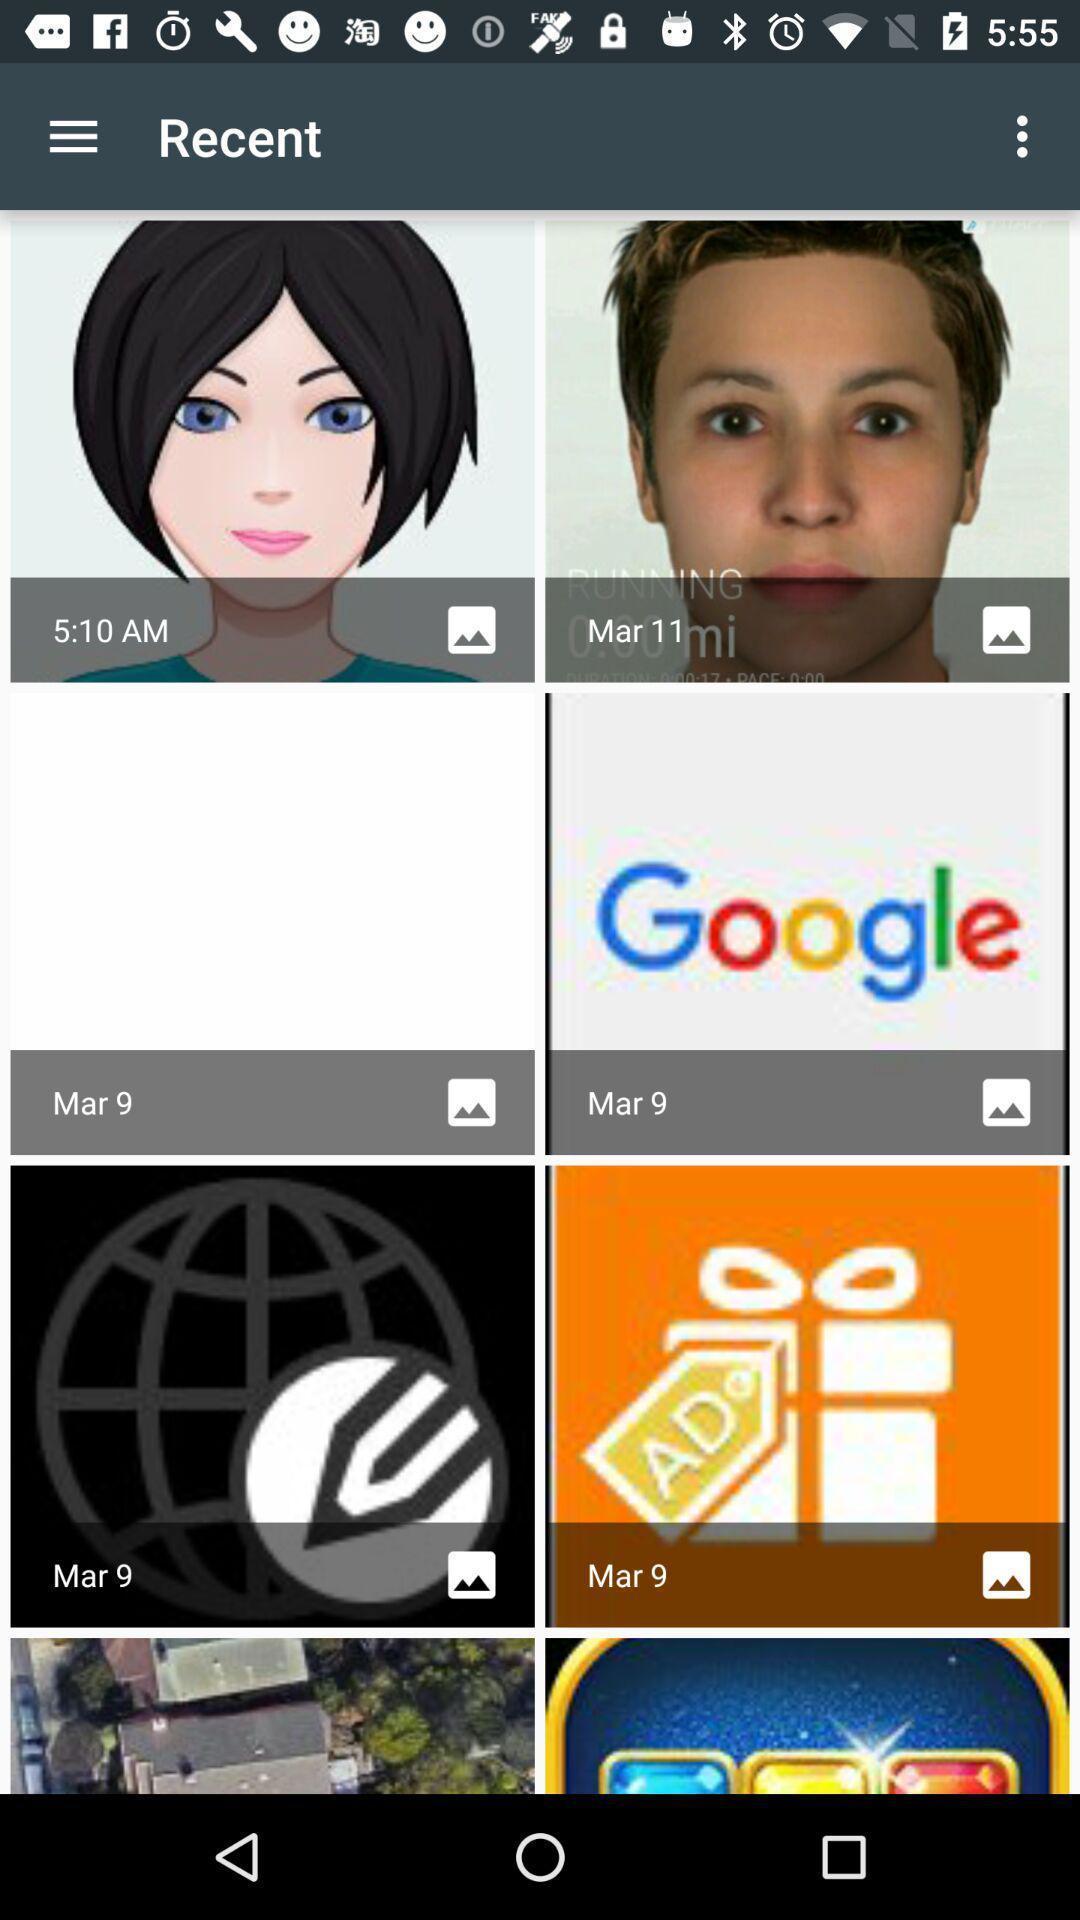Summarize the information in this screenshot. Page showing recent photos on mobile. 